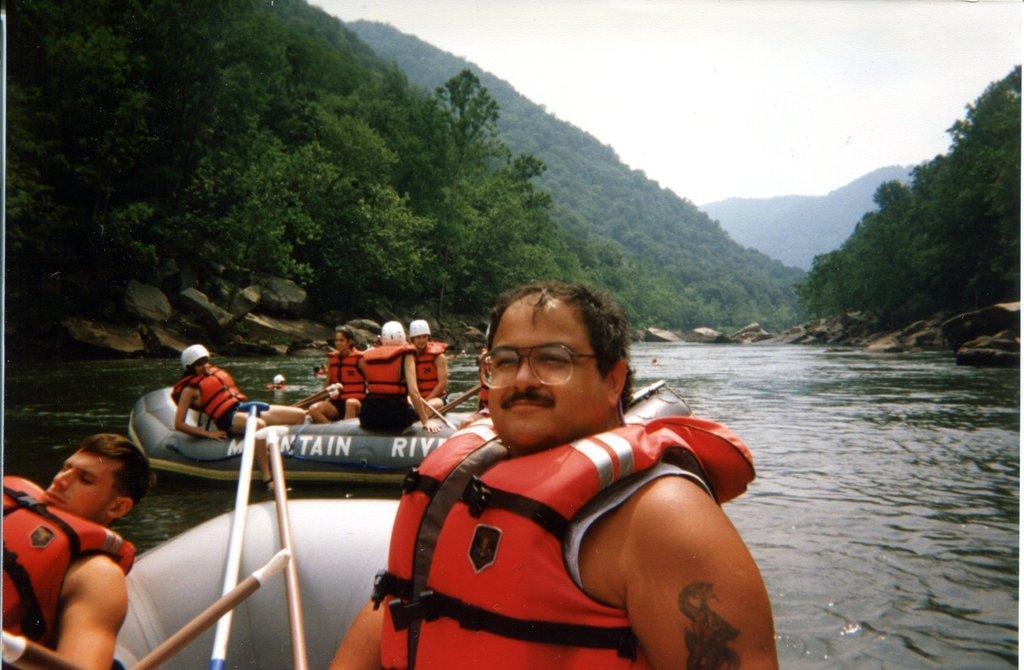Describe this image in one or two sentences. In this picture I can see there are few people in the boat and there is a lake, there are mountains covered with trees and the sky is clear. 